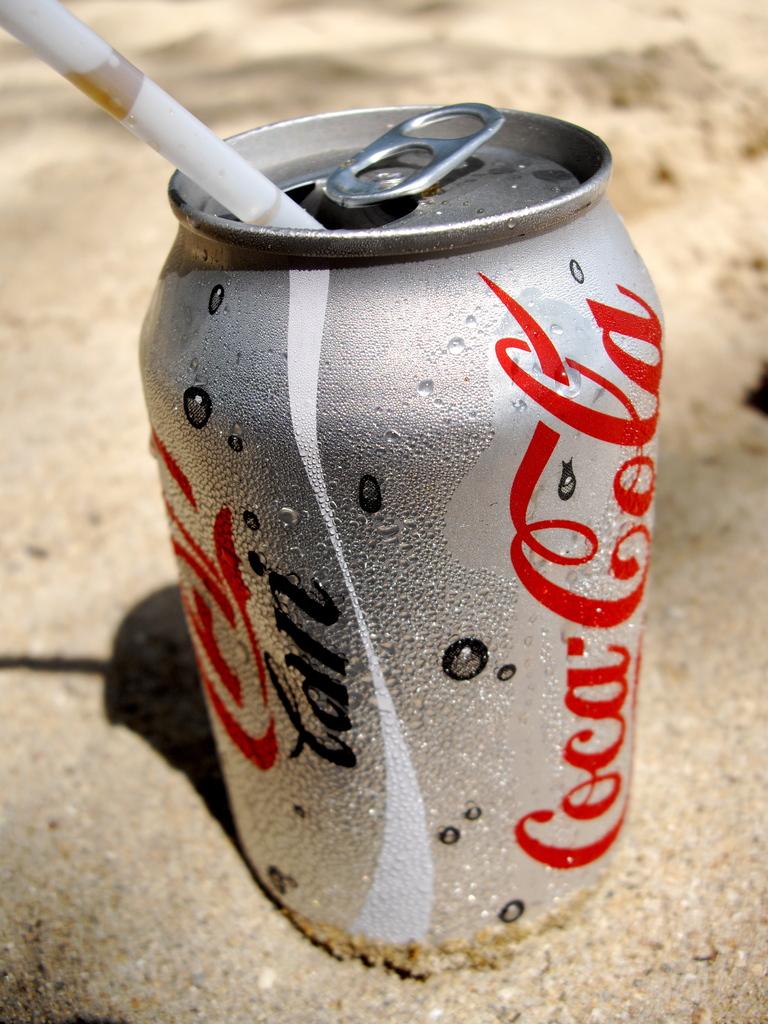What is in the can?
Provide a succinct answer. Coca cola. 